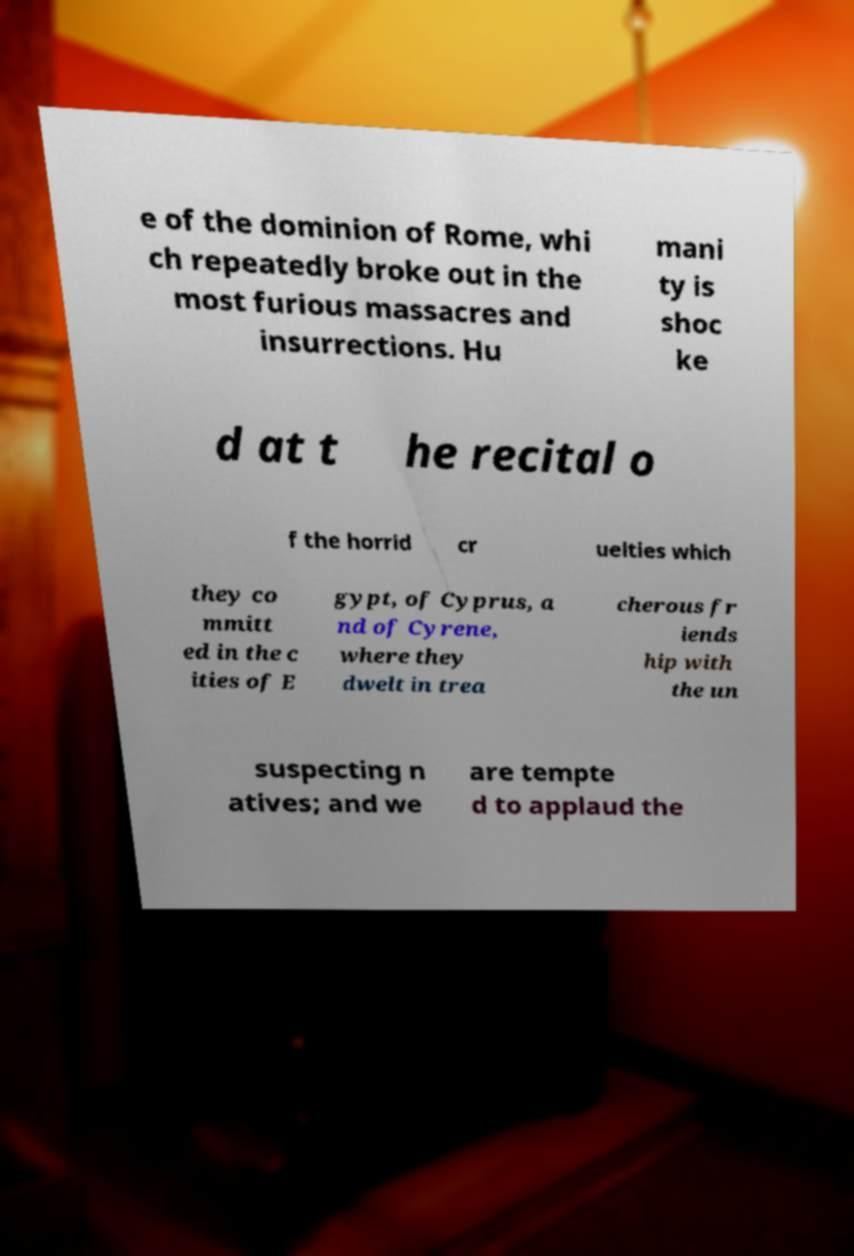Can you accurately transcribe the text from the provided image for me? e of the dominion of Rome, whi ch repeatedly broke out in the most furious massacres and insurrections. Hu mani ty is shoc ke d at t he recital o f the horrid cr uelties which they co mmitt ed in the c ities of E gypt, of Cyprus, a nd of Cyrene, where they dwelt in trea cherous fr iends hip with the un suspecting n atives; and we are tempte d to applaud the 